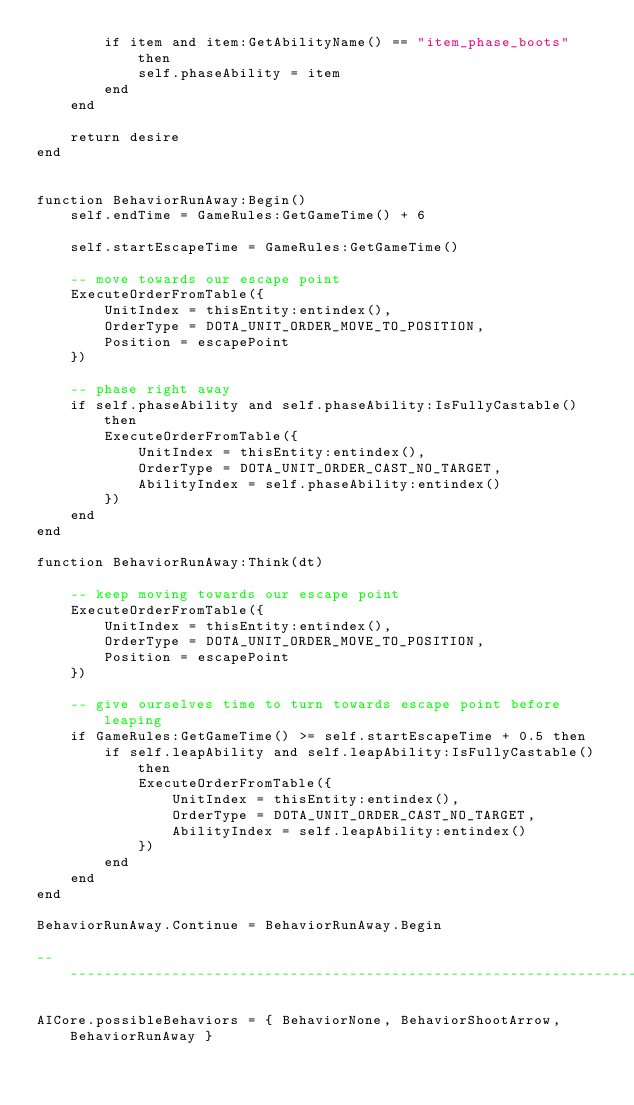<code> <loc_0><loc_0><loc_500><loc_500><_Lua_>		if item and item:GetAbilityName() == "item_phase_boots" then
			self.phaseAbility = item
		end
	end
	
	return desire
end


function BehaviorRunAway:Begin()
	self.endTime = GameRules:GetGameTime() + 6

	self.startEscapeTime = GameRules:GetGameTime()

	-- move towards our escape point
	ExecuteOrderFromTable({
		UnitIndex = thisEntity:entindex(),
		OrderType = DOTA_UNIT_ORDER_MOVE_TO_POSITION,
		Position = escapePoint
	})

	-- phase right away
	if self.phaseAbility and self.phaseAbility:IsFullyCastable() then
		ExecuteOrderFromTable({
			UnitIndex = thisEntity:entindex(),
			OrderType = DOTA_UNIT_ORDER_CAST_NO_TARGET,
			AbilityIndex = self.phaseAbility:entindex()
		})
	end
end

function BehaviorRunAway:Think(dt)

	-- keep moving towards our escape point
	ExecuteOrderFromTable({
		UnitIndex = thisEntity:entindex(),
		OrderType = DOTA_UNIT_ORDER_MOVE_TO_POSITION,
		Position = escapePoint
	})

	-- give ourselves time to turn towards escape point before leaping
	if GameRules:GetGameTime() >= self.startEscapeTime + 0.5 then
		if self.leapAbility and self.leapAbility:IsFullyCastable() then
			ExecuteOrderFromTable({
				UnitIndex = thisEntity:entindex(),
				OrderType = DOTA_UNIT_ORDER_CAST_NO_TARGET,
				AbilityIndex = self.leapAbility:entindex()
			})
		end
	end
end

BehaviorRunAway.Continue = BehaviorRunAway.Begin

--------------------------------------------------------------------------------------------------------

AICore.possibleBehaviors = { BehaviorNone, BehaviorShootArrow, BehaviorRunAway }
</code> 